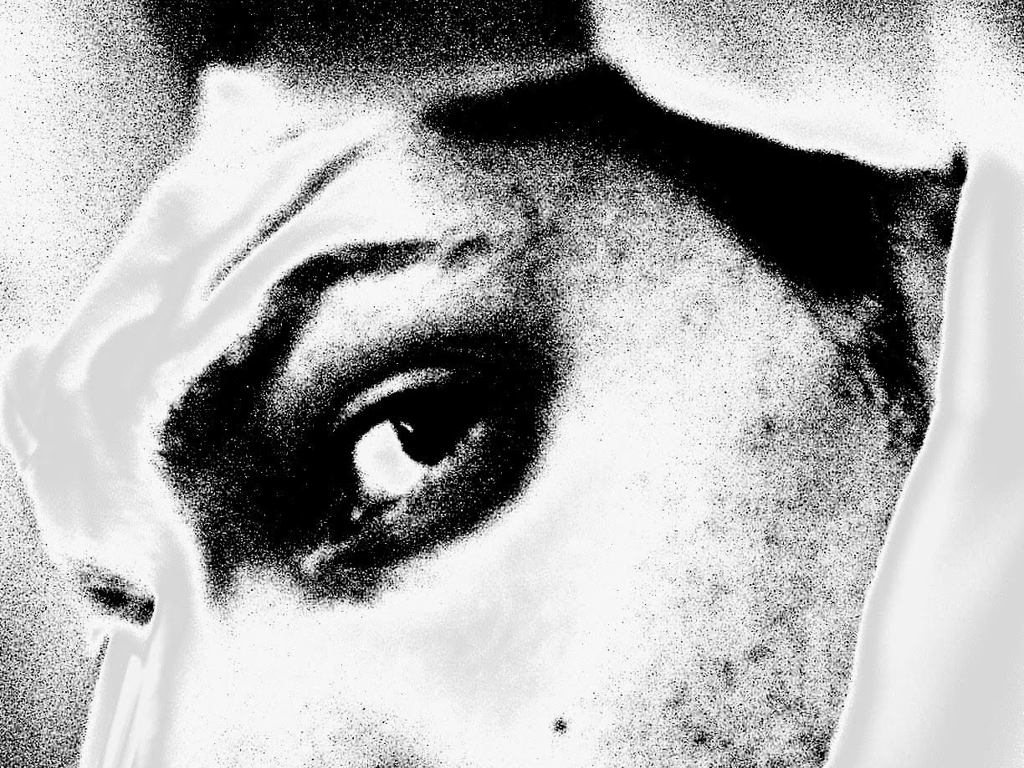Can you describe the main focus of this image? The main focus appears to be an eye, intensely captured with a stark contrast between light and shadow. It exudes a powerful expression that seems to draw the viewer into its gaze. What can you tell me about the mood conveyed by the image? The mood expressed by the image is one of drama and intensity. The high contrast and close-up of the eye give it an enigmatic quality, prompting introspection and emotional engagement. 